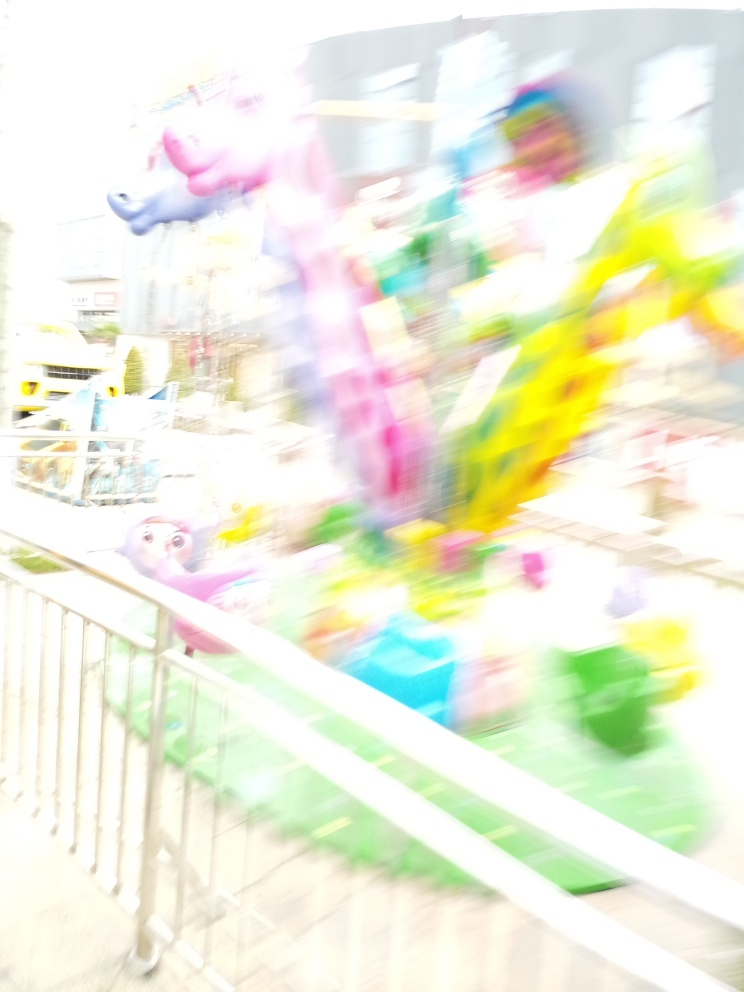What do the visible objects and their arrangement tell us about the setting? The visible objects, which appear to be inflated balloons or perhaps decorations, along with indistinct shapes and colors, suggest a festive or celebratory environment. The arrangement of these elements conveys a sense of disorderly movement, indicative of a public space like a fairground, a street festival, or an amusement park. 